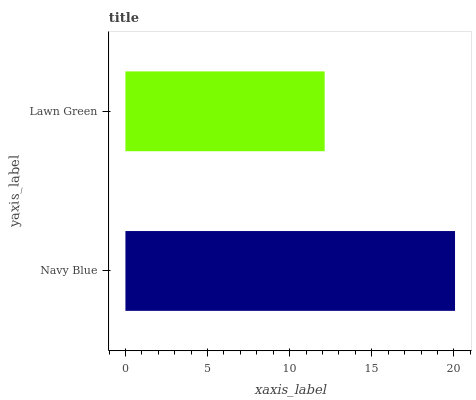Is Lawn Green the minimum?
Answer yes or no. Yes. Is Navy Blue the maximum?
Answer yes or no. Yes. Is Lawn Green the maximum?
Answer yes or no. No. Is Navy Blue greater than Lawn Green?
Answer yes or no. Yes. Is Lawn Green less than Navy Blue?
Answer yes or no. Yes. Is Lawn Green greater than Navy Blue?
Answer yes or no. No. Is Navy Blue less than Lawn Green?
Answer yes or no. No. Is Navy Blue the high median?
Answer yes or no. Yes. Is Lawn Green the low median?
Answer yes or no. Yes. Is Lawn Green the high median?
Answer yes or no. No. Is Navy Blue the low median?
Answer yes or no. No. 